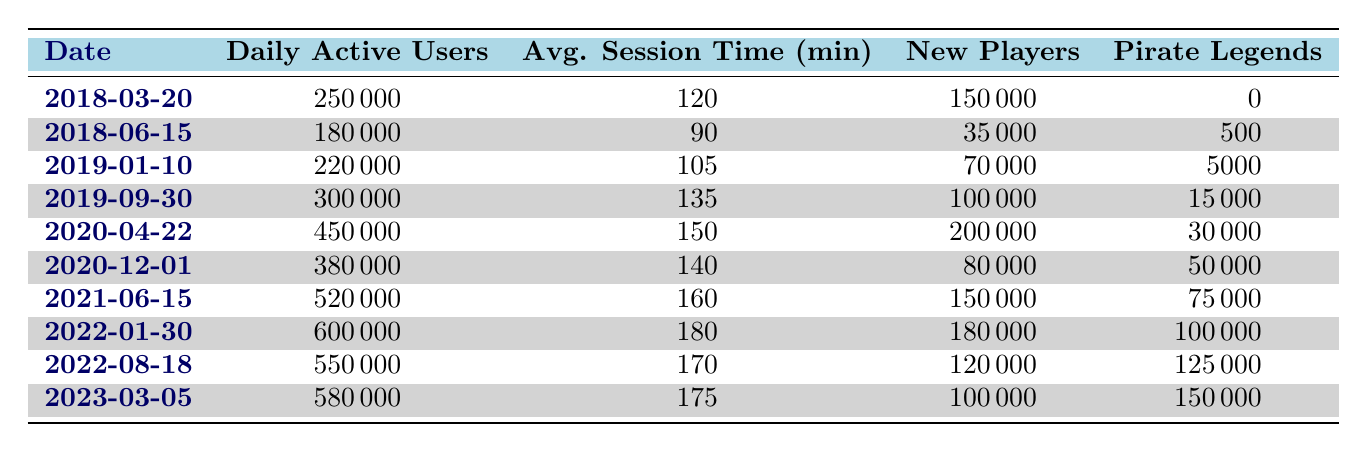What is the date with the highest daily active users? Looking at the "Daily Active Users" column, the highest number is 600000, which occurs on 2022-01-30.
Answer: 2022-01-30 How many new players joined on 2020-04-22? Referring to the corresponding row for 2020-04-22, the "New Players" value is 200000.
Answer: 200000 What is the average session time across all dates provided? To find the average session time, sum the session times: 120 + 90 + 105 + 135 + 150 + 140 + 160 + 180 + 170 + 175 = 1305 minutes. Then, divide by the total number of entries (10): 1305 / 10 = 130.5.
Answer: 130.5 Was there a reported increase in daily active users from 2021-06-15 to 2022-01-30? The daily active users on 2021-06-15 were 520000 and on 2022-01-30 were 600000. Since 600000 is greater than 520000, there was indeed an increase.
Answer: Yes What is the total number of pirate legends counted by the end of 2022? The last date in the table is 2023-03-05 with 150000 pirate legends. Adding the totals from each date gives: 0 + 500 + 5000 + 15000 + 30000 + 50000 + 75000 + 100000 + 125000 + 150000 = 250000.
Answer: 250000 Which platform had the highest number of daily active users and on what date? The highest daily active users recorded were 600000 on 2022-01-30 for the PC platform.
Answer: PC on 2022-01-30 What is the percentage of new players on 2019-09-30 compared to daily active users? For 2019-09-30, new players were 100000, and daily active users were 300000. Calculate the percentage: (100000 / 300000) * 100 = 33.33%.
Answer: 33.33% Did more players become Pirate Legends on 2020-12-01 than on 2019-01-10? On 2020-12-01, the pirate legend count was 50000 while on 2019-01-10, it was 5000. Since 50000 is greater than 5000, more players became Pirate Legends on 2020-12-01.
Answer: Yes How many total new players joined during the entire timeframe? To find the total new players, we add the new players from all dates together: 150000 + 35000 + 70000 + 100000 + 200000 + 80000 + 150000 + 180000 + 120000 + 100000 = 1110000.
Answer: 1110000 